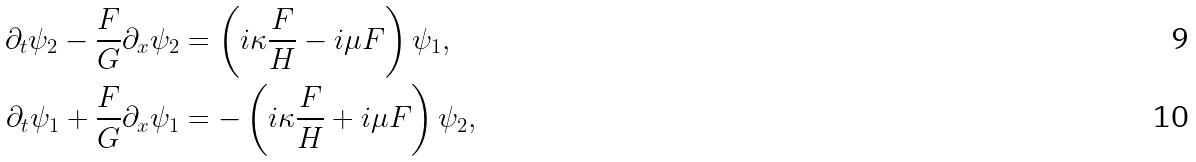<formula> <loc_0><loc_0><loc_500><loc_500>\partial _ { t } \psi _ { 2 } - \frac { F } { G } \partial _ { x } \psi _ { 2 } & = \left ( i \kappa \frac { F } { H } - i \mu F \right ) \psi _ { 1 } , \\ \partial _ { t } \psi _ { 1 } + \frac { F } { G } \partial _ { x } \psi _ { 1 } & = - \left ( i \kappa \frac { F } { H } + i \mu F \right ) \psi _ { 2 } ,</formula> 